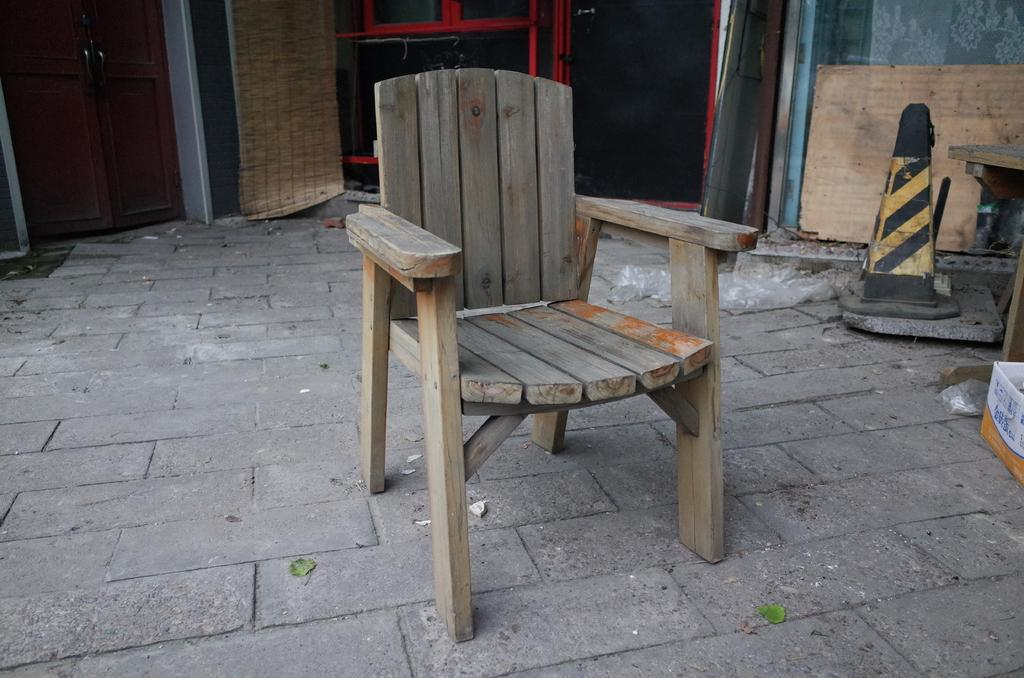What type of chair is in the image? There is a wooden chair in the image. What object can be seen on the right side of the image? There is a traffic cone on the right side of the image. What else is on the right side of the image besides the traffic cone? There is a box and other items on the right side of the image. What architectural feature is visible in the background of the image? There are doors visible in the background of the image. Can you see the owl's throat in the image? There is no owl present in the image, so it is not possible to see its throat. 